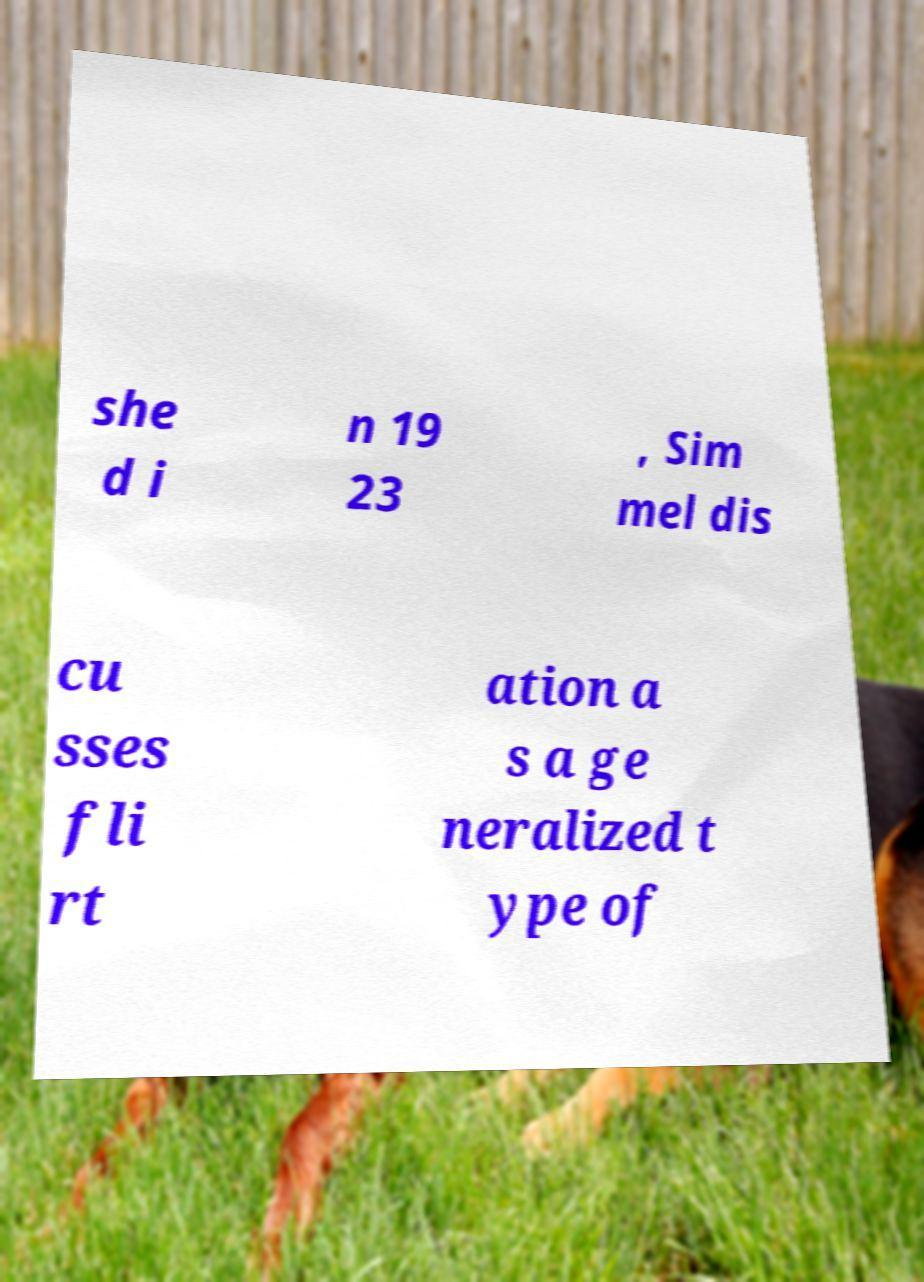What messages or text are displayed in this image? I need them in a readable, typed format. she d i n 19 23 , Sim mel dis cu sses fli rt ation a s a ge neralized t ype of 